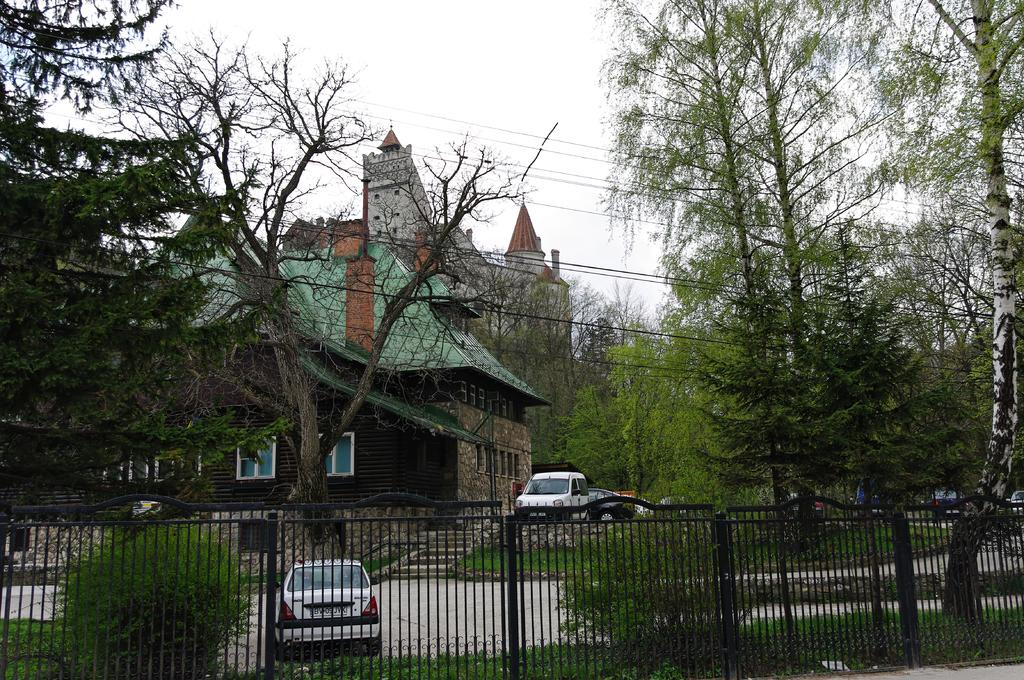What type of barrier can be seen in the image? There is a fence in the image. What type of vegetation is present in the image? There are plants and trees in the image. What can be seen on the road in the image? Cars are parked on the road in the image. What else can be seen in the image besides the fence, plants, and cars? Wires are visible in the image. What is visible in the background of the image? There are buildings and the sky in the background of the image. What type of underwear is hanging on the fence in the image? There is no underwear present in the image; it only features a fence, plants, cars, wires, buildings, and the sky. What type of celery can be seen growing in the image? There is no celery present in the image; it only features plants and trees, but no specific type of vegetation is mentioned. What shape can be seen in the sky in the image? The sky in the image is visible, but no specific shapes or patterns are mentioned, so it cannot be determined if a circle or any other shape is present. 